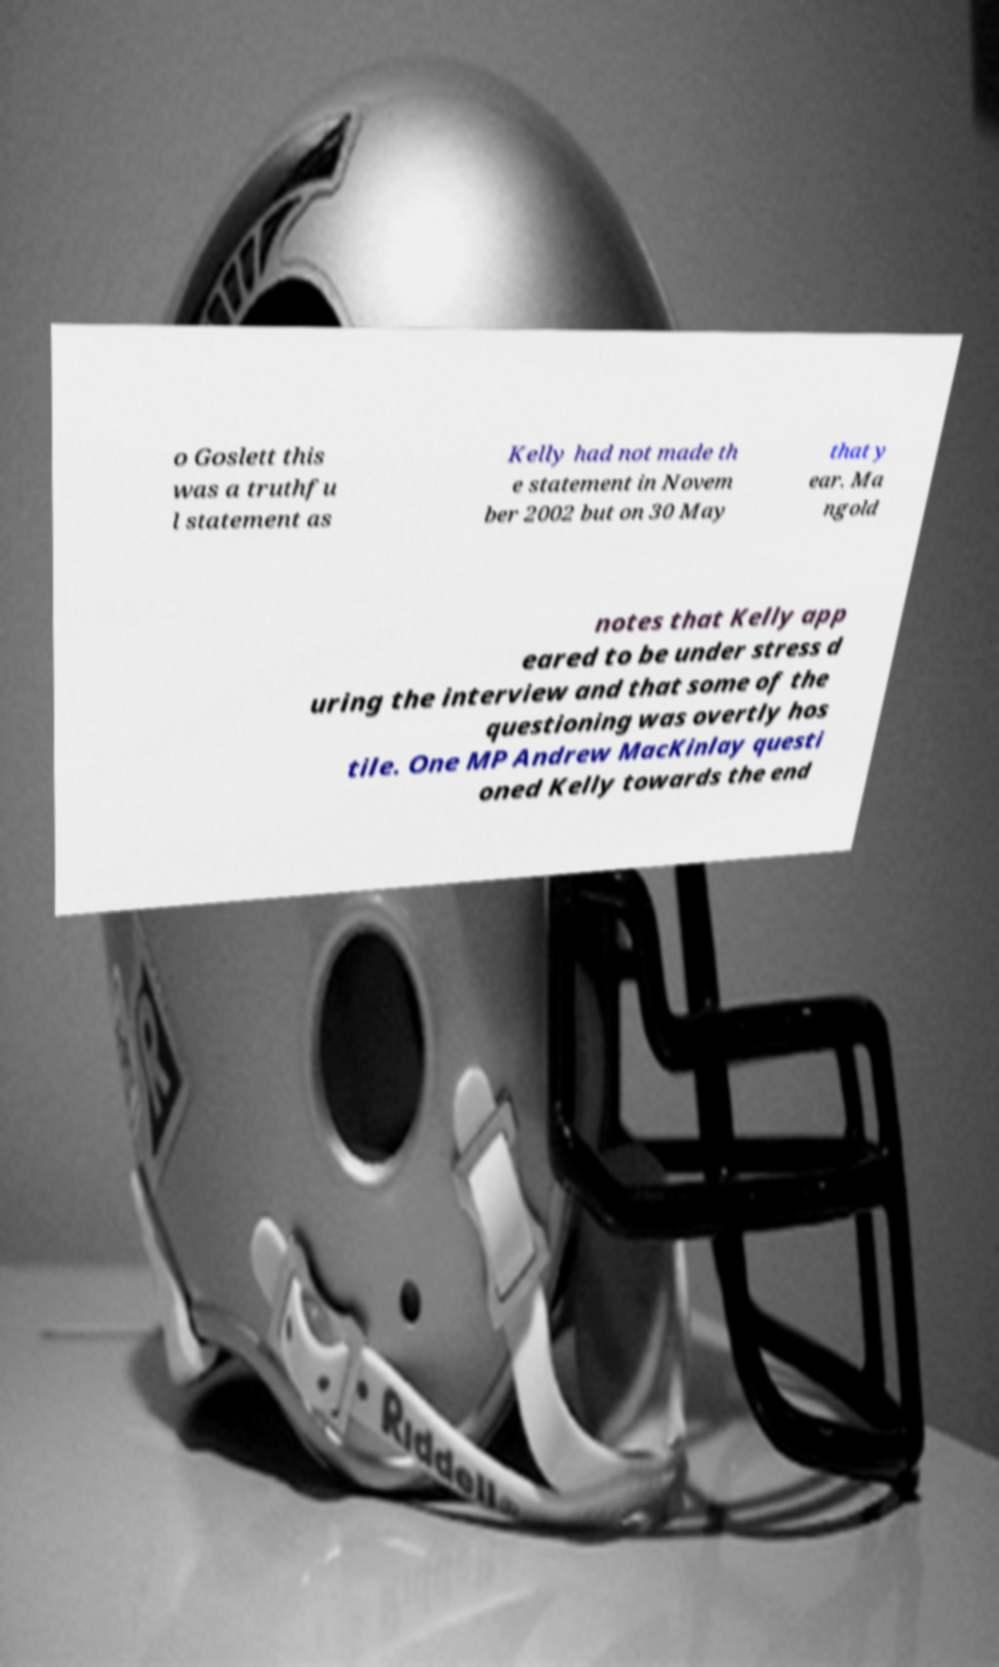For documentation purposes, I need the text within this image transcribed. Could you provide that? o Goslett this was a truthfu l statement as Kelly had not made th e statement in Novem ber 2002 but on 30 May that y ear. Ma ngold notes that Kelly app eared to be under stress d uring the interview and that some of the questioning was overtly hos tile. One MP Andrew MacKinlay questi oned Kelly towards the end 